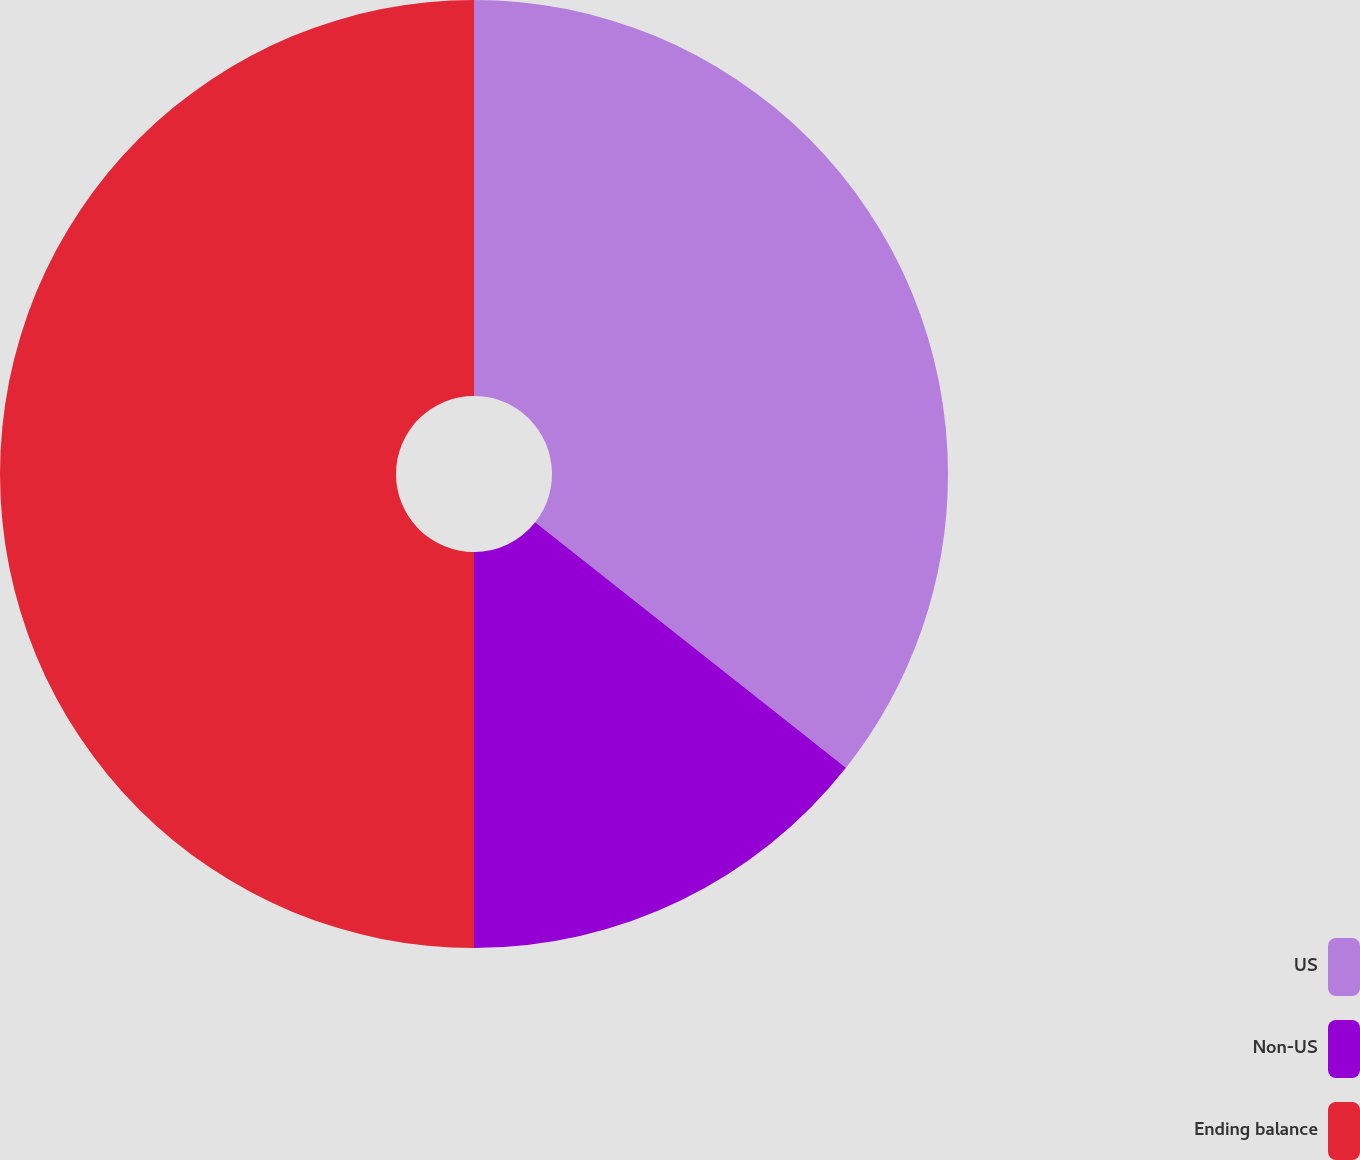<chart> <loc_0><loc_0><loc_500><loc_500><pie_chart><fcel>US<fcel>Non-US<fcel>Ending balance<nl><fcel>35.64%<fcel>14.36%<fcel>50.0%<nl></chart> 